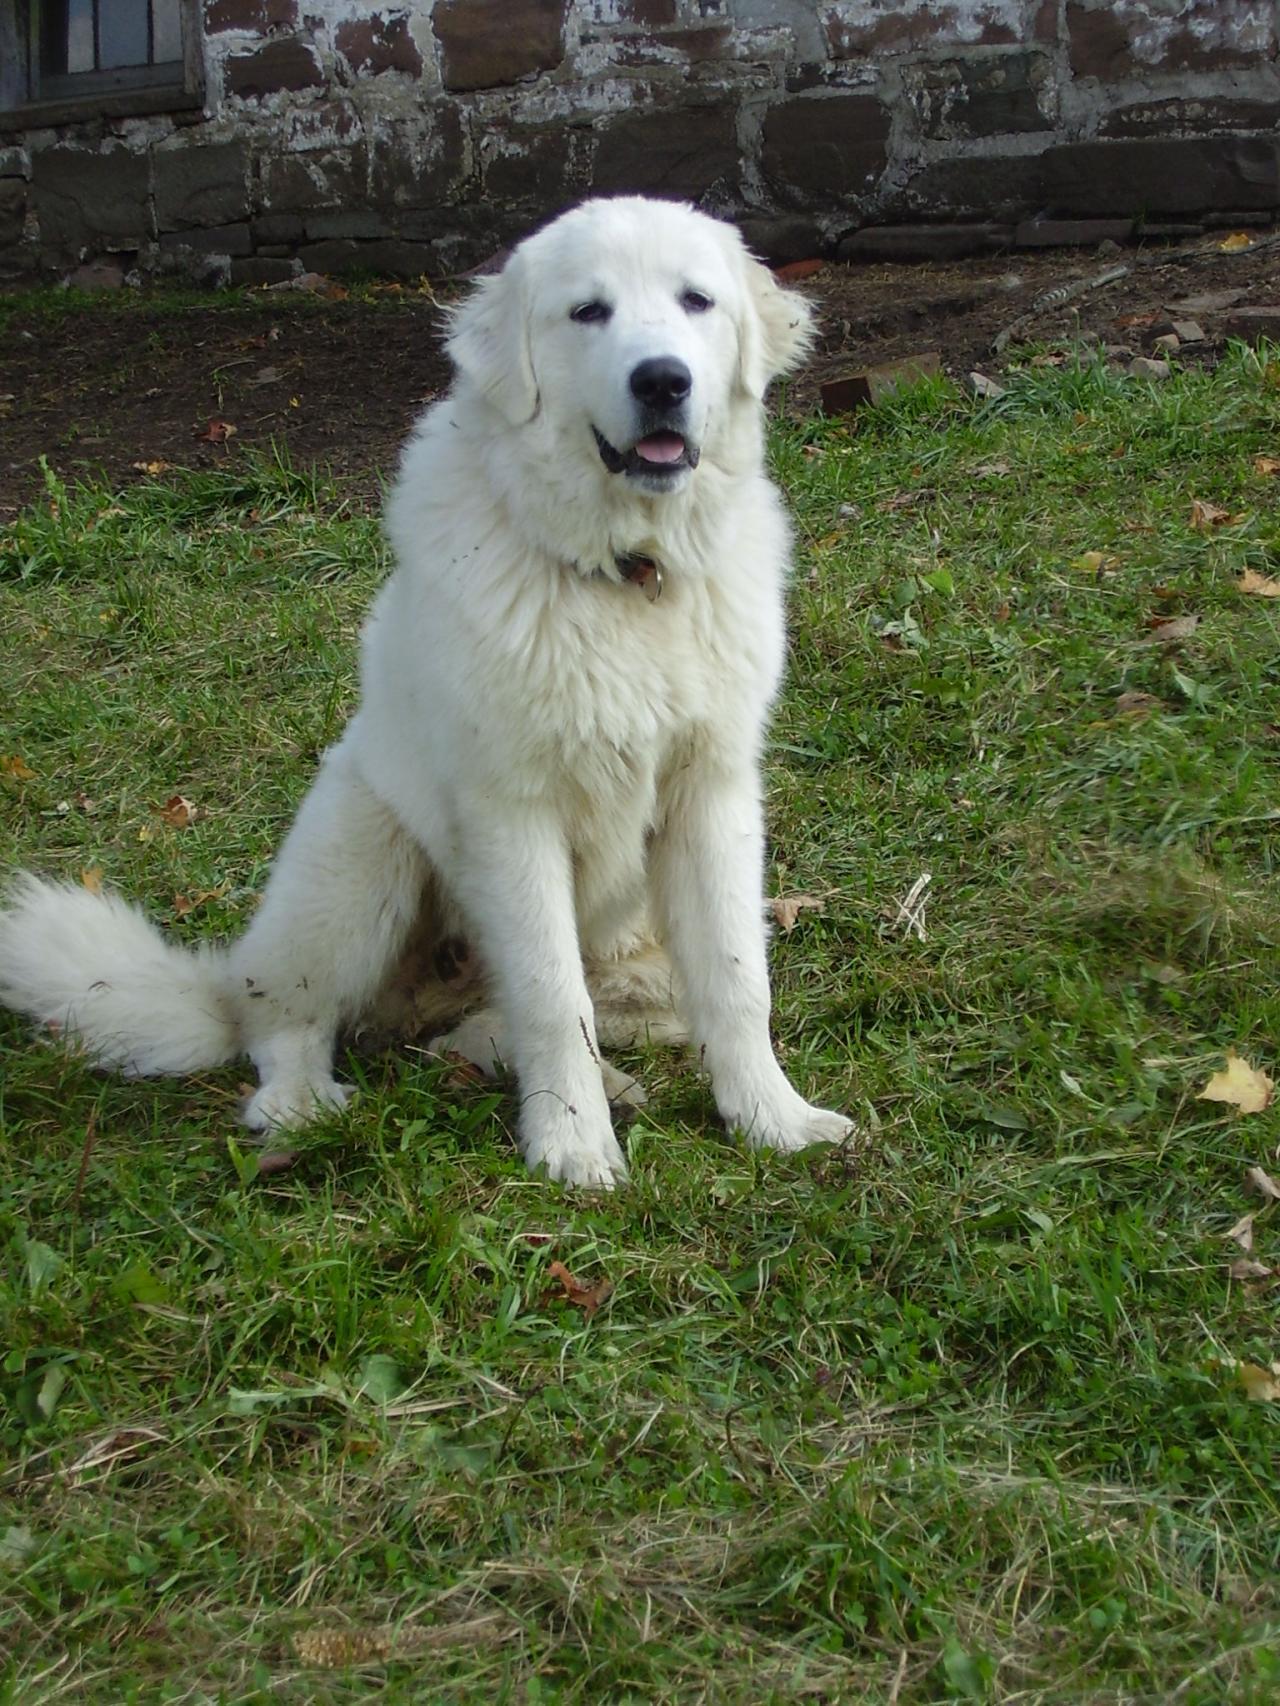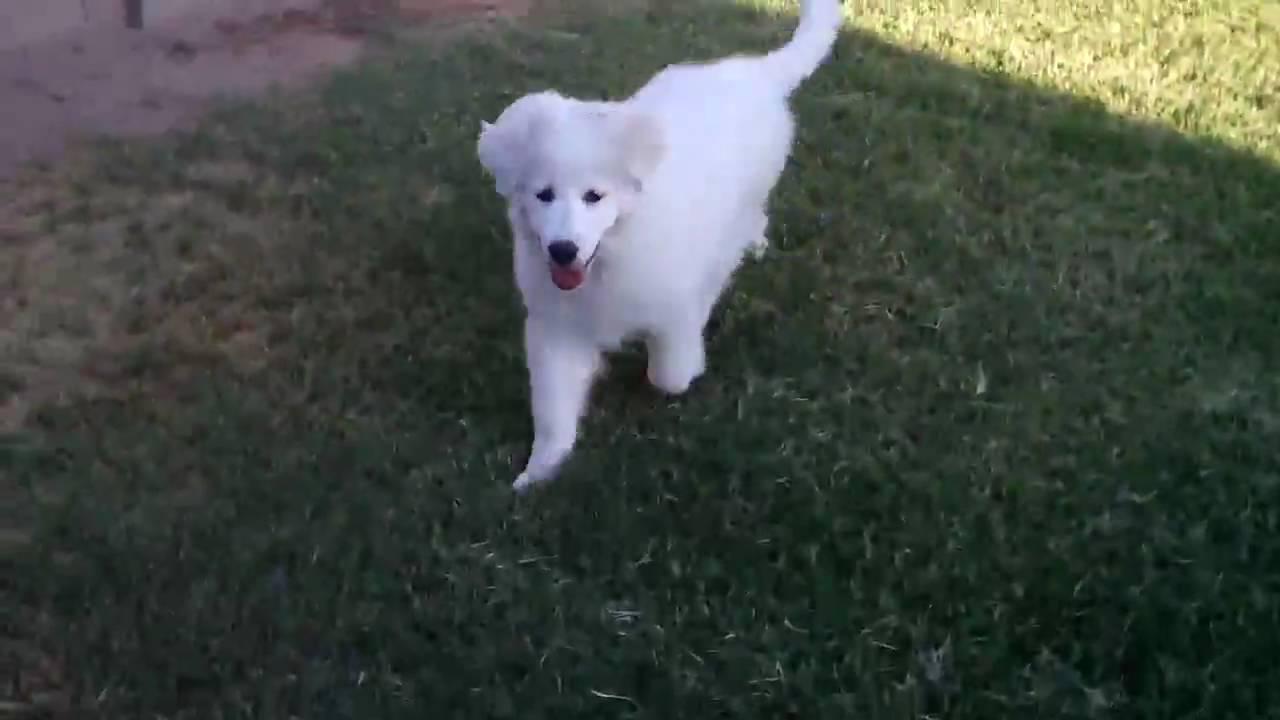The first image is the image on the left, the second image is the image on the right. Evaluate the accuracy of this statement regarding the images: "An image shows one white dog reclining on the grass with its front paws extended.". Is it true? Answer yes or no. No. The first image is the image on the left, the second image is the image on the right. Given the left and right images, does the statement "The dog in the image on the left is lying on the grass." hold true? Answer yes or no. No. 